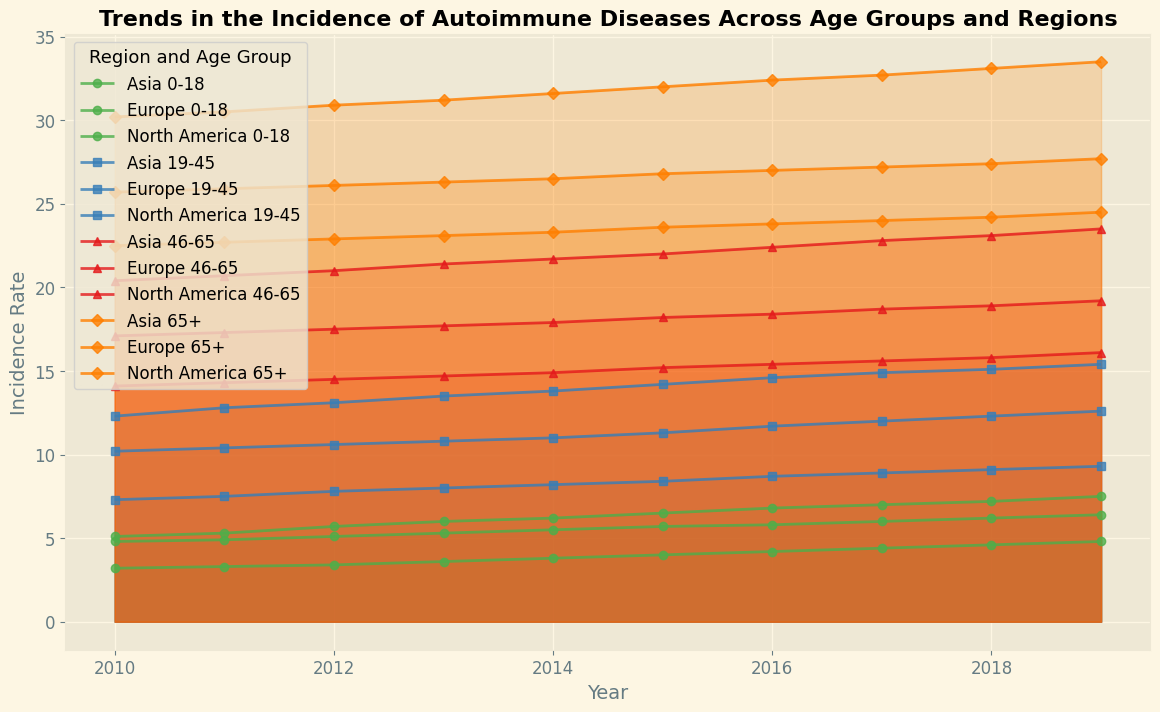Which age group in North America had the highest incidence rate in 2019? To determine the highest incidence rate for North America in 2019, compare the incidence rates for each age group. The rates are 7.5 (0-18), 15.4 (19-45), 23.5 (46-65), and 33.5 (65+). The highest is 33.5 for the 65+ age group.
Answer: 65+ How did the incidence rate of autoimmune diseases among the 0-18 age group in Europe change from 2010 to 2019? Subtract the incidence rate for the 0-18 age group in Europe in 2010 (4.8) from the rate in 2019 (6.4). The difference is 6.4 - 4.8 = 1.6, indicating an increase.
Answer: Increased by 1.6 What is the average incidence rate for the 19-45 age group in Asia over the 10-year period? Add the incidence rates for the 19-45 age group in Asia: 7.3, 7.5, 7.8, 8.0, 8.2, 8.4, 8.7, 8.9, 9.1, and 9.3. The sum is 83.2. Divide this by the number of years (10) to get the average: 83.2 / 10 = 8.32.
Answer: 8.32 Which region had the lowest incidence rate for the 46-65 age group in 2015, and what was the rate? Compare the incidence rates for the 46-65 age group in 2015 across all regions: North America (22.0), Europe (18.2), and Asia (15.2). The lowest rate is 15.2 in Asia.
Answer: Asia, 15.2 By how much did the incidence rate for the 65+ age group in Europe increase from 2010 to 2019? Subtract the incidence rate for the 65+ age group in Europe in 2010 (25.7) from the rate in 2019 (27.7). The difference is 27.7 - 25.7 = 2.0, indicating an increase.
Answer: Increased by 2.0 In which year did the 0-18 age group in North America see the highest increment in incidence rate, and what was the rate of increment? Observe the year-on-year changes in incidence rates for the 0-18 age group in North America. The highest increment is from 2011 (5.3) to 2012 (5.7) with a change of 5.7 - 5.3 = 0.4.
Answer: From 2011 to 2012, increment of 0.4 Compare the incidence rates of the 46-65 age group in Asia and North America in 2019. Which region had a higher rate and by how much? The incidence rate for the 46-65 age group in Asia in 2019 is 16.1, while in North America it is 23.5. The difference is 23.5 - 16.1 = 7.4, with North America having the higher rate.
Answer: North America, higher by 7.4 What is the overall trend in the incidence rate of the 19-45 age group in Europe from 2010 to 2019? Examine the incidence rates for the 19-45 age group in Europe over the years provided: the rates consistently increase from 10.2 in 2010 to 12.6 in 2019.
Answer: Increasing trend Which age group in any region had the smallest change in incidence rate from 2010 to 2019? Calculate the changes in incidence rates for all age groups in each region. The smallest change is in Europe's 65+ age group, increasing from 25.7 in 2010 to 27.7 in 2019, a change of 2.0.
Answer: 65+ in Europe, change of 2.0 If the incidence rate among the 19-45 age group in North America continued to increase at the same rate from 2019, what would the rate be in 2021? The average yearly increment from 2010 (12.3) to 2019 (15.4) is (15.4 - 12.3) / 9 ≈ 0.344. Adding this increment for two more years: 15.4 + 2 * 0.344 ≈ 16.1.
Answer: Approximately 16.1 